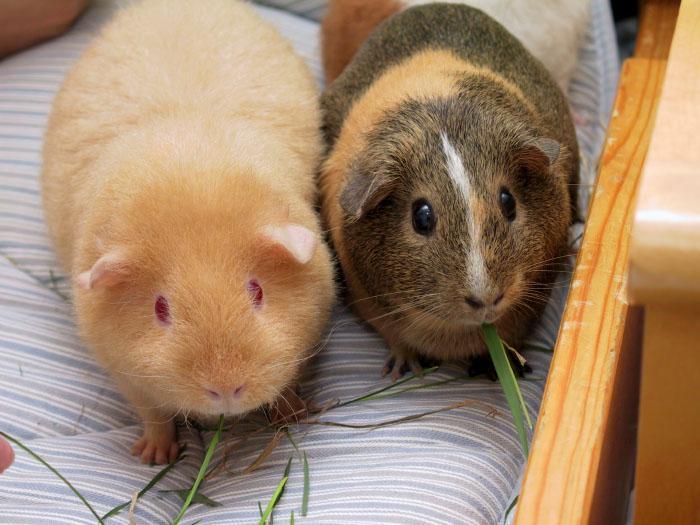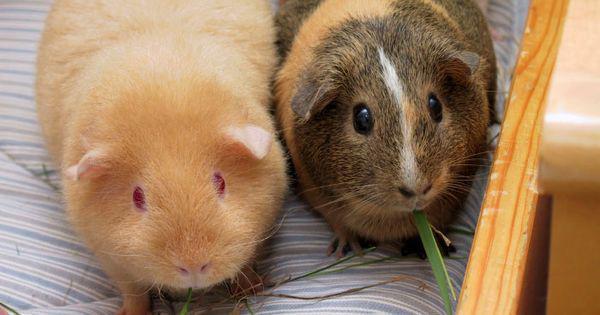The first image is the image on the left, the second image is the image on the right. For the images shown, is this caption "There are two guinea pigs in one image." true? Answer yes or no. Yes. The first image is the image on the left, the second image is the image on the right. Examine the images to the left and right. Is the description "There are at least four guinea pigs in total." accurate? Answer yes or no. Yes. 